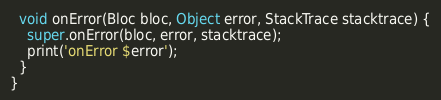Convert code to text. <code><loc_0><loc_0><loc_500><loc_500><_Dart_>  void onError(Bloc bloc, Object error, StackTrace stacktrace) {
    super.onError(bloc, error, stacktrace);
    print('onError $error');
  }
}
</code> 